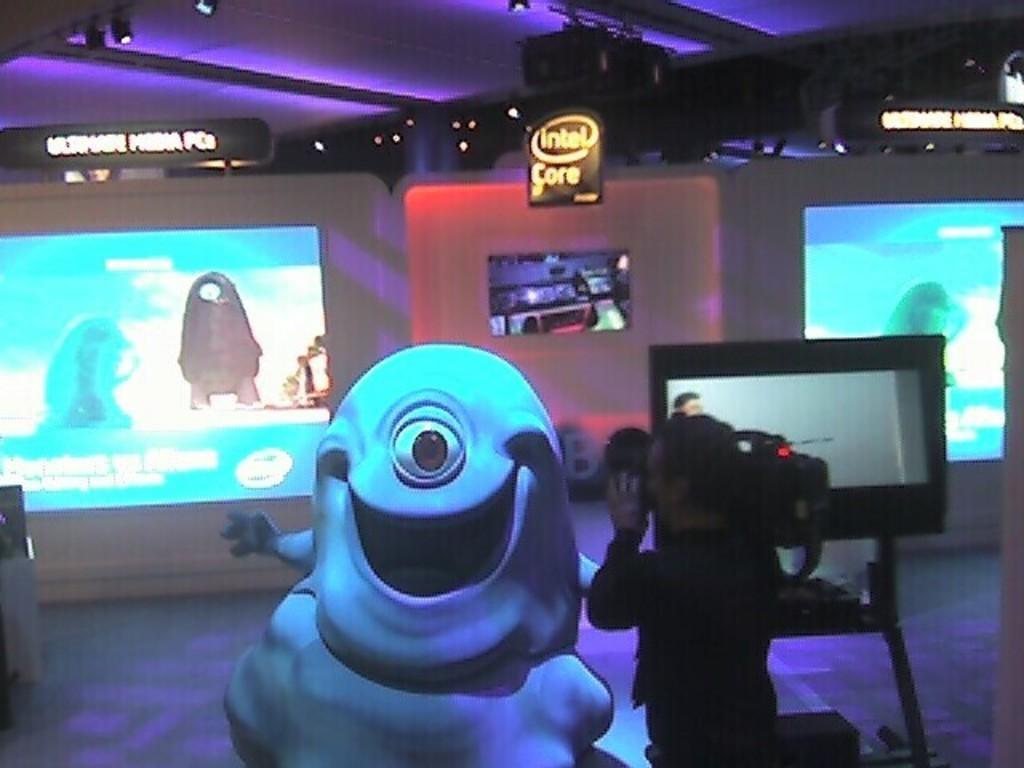How would you summarize this image in a sentence or two? In the image we can see a toy and a person standing, wearing clothes and holding a video camera in hands. Here we can see the screens and the floor. 